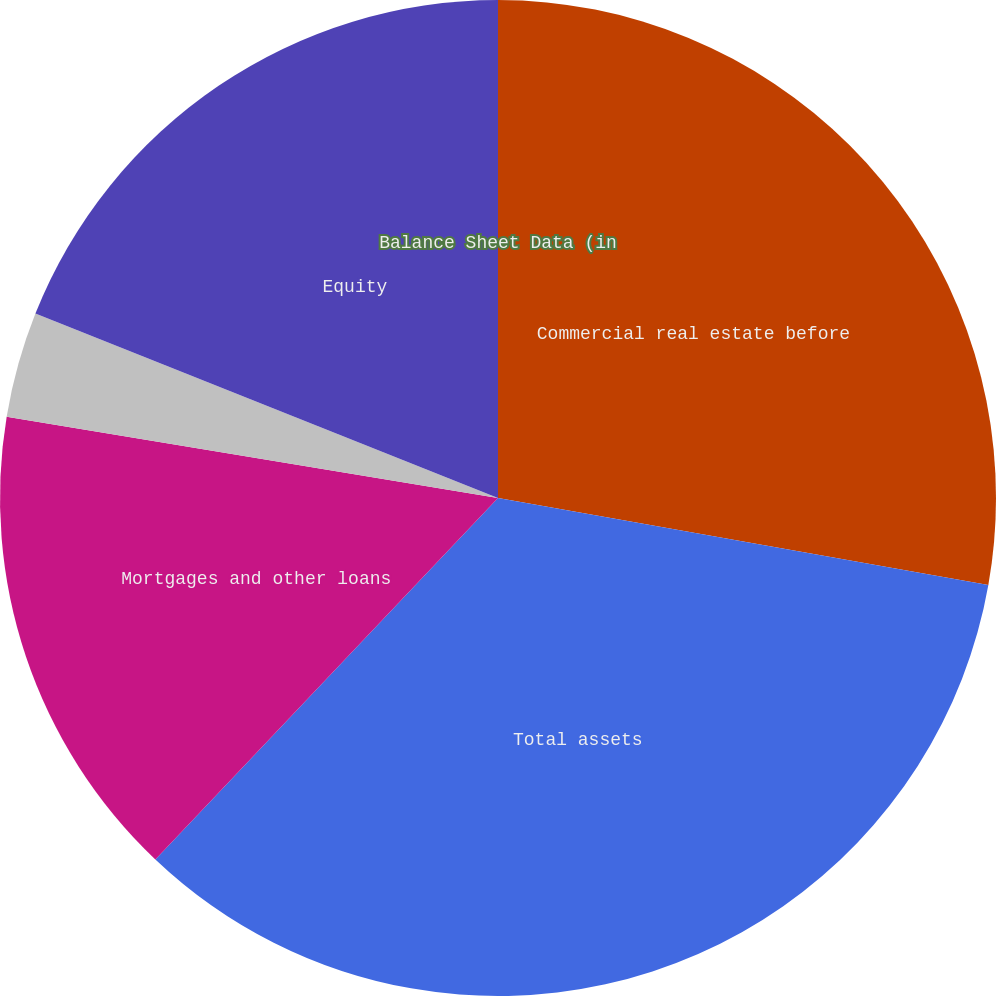<chart> <loc_0><loc_0><loc_500><loc_500><pie_chart><fcel>Balance Sheet Data (in<fcel>Commercial real estate before<fcel>Total assets<fcel>Mortgages and other loans<fcel>Unnamed: 4<fcel>Equity<nl><fcel>0.0%<fcel>27.79%<fcel>34.28%<fcel>15.53%<fcel>3.43%<fcel>18.96%<nl></chart> 